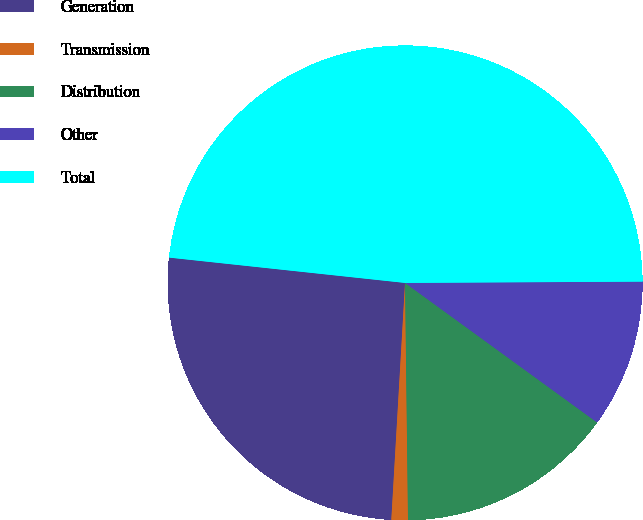<chart> <loc_0><loc_0><loc_500><loc_500><pie_chart><fcel>Generation<fcel>Transmission<fcel>Distribution<fcel>Other<fcel>Total<nl><fcel>25.78%<fcel>1.12%<fcel>14.8%<fcel>10.09%<fcel>48.21%<nl></chart> 